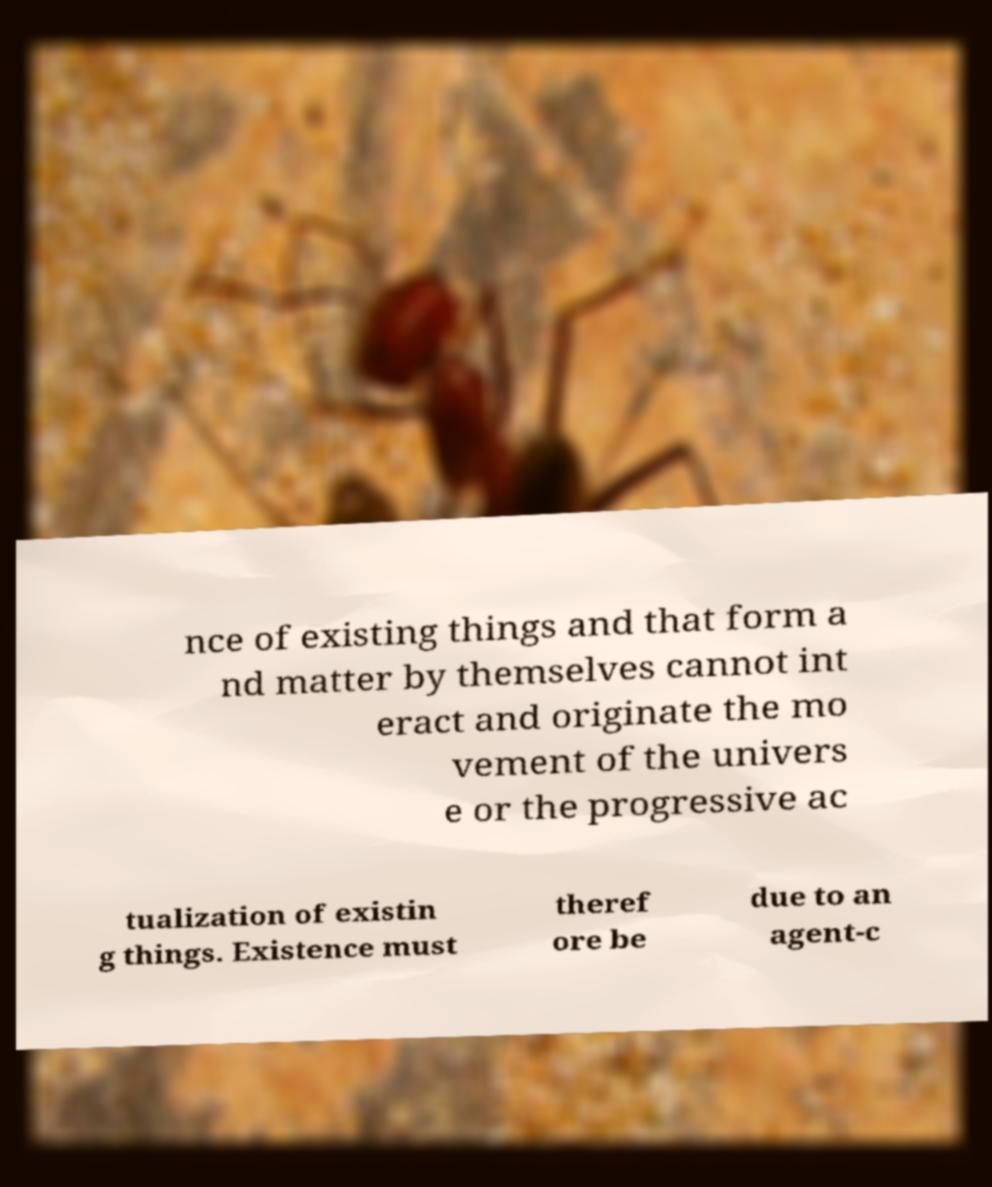For documentation purposes, I need the text within this image transcribed. Could you provide that? nce of existing things and that form a nd matter by themselves cannot int eract and originate the mo vement of the univers e or the progressive ac tualization of existin g things. Existence must theref ore be due to an agent-c 